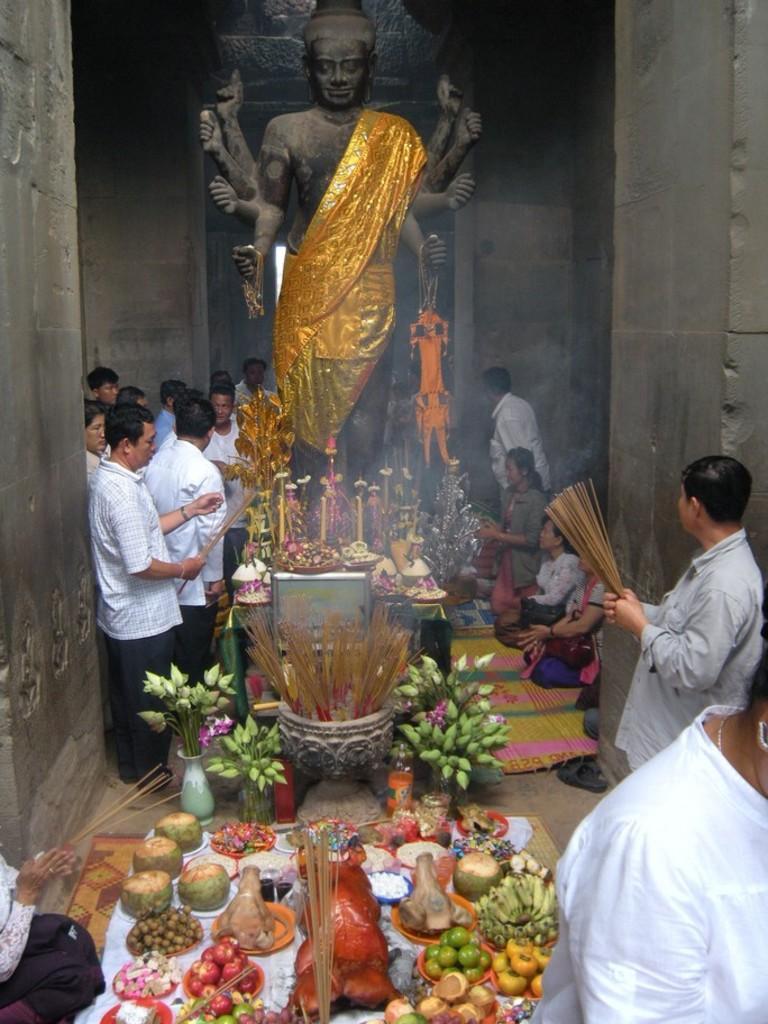Please provide a concise description of this image. In this image we can see a statue of the god and we can also see people, fruits, mats and some other objects. 